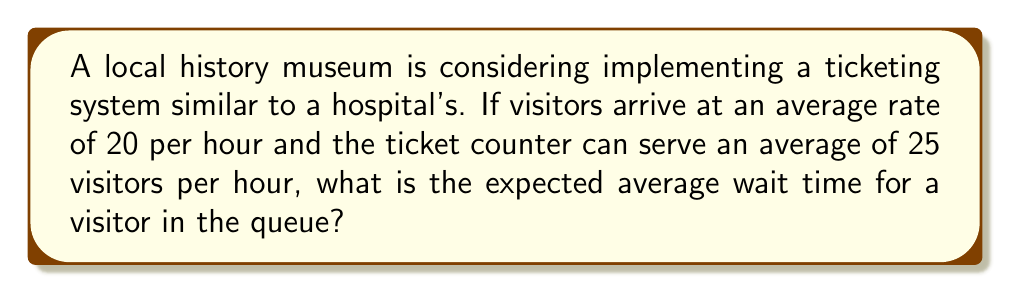Give your solution to this math problem. To solve this problem, we'll use the M/M/1 queuing model, which is often used in simple queuing theory applications. This model assumes a single server with Poisson arrival and service rates.

Let's define our variables:
$\lambda$ = arrival rate = 20 visitors/hour
$\mu$ = service rate = 25 visitors/hour

Step 1: Calculate the utilization factor $\rho$
$$\rho = \frac{\lambda}{\mu} = \frac{20}{25} = 0.8$$

Step 2: Calculate the average number of visitors in the queue $L_q$
$$L_q = \frac{\rho^2}{1-\rho} = \frac{0.8^2}{1-0.8} = \frac{0.64}{0.2} = 3.2$$

Step 3: Use Little's Law to calculate the average wait time $W_q$
$$W_q = \frac{L_q}{\lambda}$$

Substituting the values:
$$W_q = \frac{3.2}{20} = 0.16\text{ hours} = 9.6\text{ minutes}$$

Therefore, the expected average wait time for a visitor in the queue is 9.6 minutes.
Answer: 9.6 minutes 